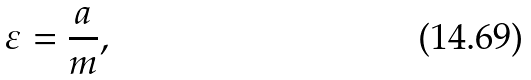<formula> <loc_0><loc_0><loc_500><loc_500>\varepsilon = \frac { a } { m } ,</formula> 